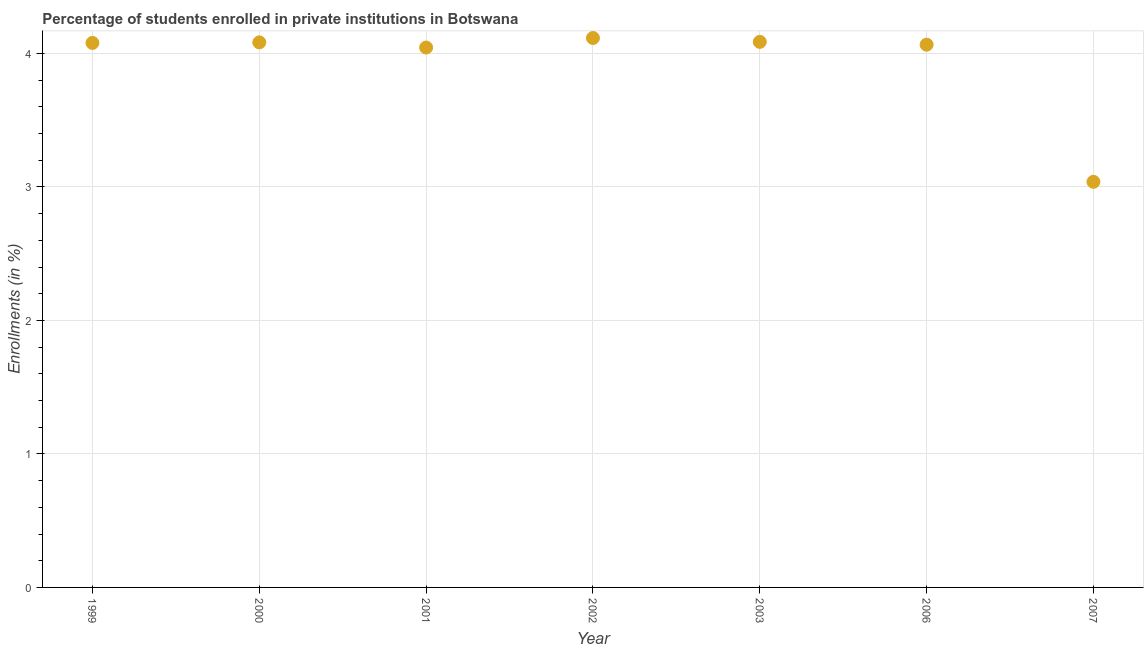What is the enrollments in private institutions in 1999?
Your answer should be very brief. 4.08. Across all years, what is the maximum enrollments in private institutions?
Your answer should be compact. 4.12. Across all years, what is the minimum enrollments in private institutions?
Keep it short and to the point. 3.04. What is the sum of the enrollments in private institutions?
Provide a short and direct response. 27.51. What is the difference between the enrollments in private institutions in 1999 and 2007?
Make the answer very short. 1.04. What is the average enrollments in private institutions per year?
Offer a very short reply. 3.93. What is the median enrollments in private institutions?
Your response must be concise. 4.08. In how many years, is the enrollments in private institutions greater than 3 %?
Make the answer very short. 7. What is the ratio of the enrollments in private institutions in 1999 to that in 2006?
Give a very brief answer. 1. Is the enrollments in private institutions in 2003 less than that in 2006?
Offer a very short reply. No. Is the difference between the enrollments in private institutions in 1999 and 2000 greater than the difference between any two years?
Keep it short and to the point. No. What is the difference between the highest and the second highest enrollments in private institutions?
Provide a succinct answer. 0.03. What is the difference between the highest and the lowest enrollments in private institutions?
Give a very brief answer. 1.08. Does the enrollments in private institutions monotonically increase over the years?
Ensure brevity in your answer.  No. How many dotlines are there?
Ensure brevity in your answer.  1. Does the graph contain any zero values?
Provide a short and direct response. No. Does the graph contain grids?
Provide a short and direct response. Yes. What is the title of the graph?
Your answer should be very brief. Percentage of students enrolled in private institutions in Botswana. What is the label or title of the Y-axis?
Offer a very short reply. Enrollments (in %). What is the Enrollments (in %) in 1999?
Your answer should be very brief. 4.08. What is the Enrollments (in %) in 2000?
Ensure brevity in your answer.  4.08. What is the Enrollments (in %) in 2001?
Ensure brevity in your answer.  4.04. What is the Enrollments (in %) in 2002?
Your answer should be very brief. 4.12. What is the Enrollments (in %) in 2003?
Your answer should be very brief. 4.09. What is the Enrollments (in %) in 2006?
Provide a succinct answer. 4.07. What is the Enrollments (in %) in 2007?
Give a very brief answer. 3.04. What is the difference between the Enrollments (in %) in 1999 and 2000?
Provide a succinct answer. -0. What is the difference between the Enrollments (in %) in 1999 and 2001?
Keep it short and to the point. 0.03. What is the difference between the Enrollments (in %) in 1999 and 2002?
Make the answer very short. -0.04. What is the difference between the Enrollments (in %) in 1999 and 2003?
Your answer should be very brief. -0.01. What is the difference between the Enrollments (in %) in 1999 and 2006?
Offer a terse response. 0.01. What is the difference between the Enrollments (in %) in 1999 and 2007?
Provide a short and direct response. 1.04. What is the difference between the Enrollments (in %) in 2000 and 2001?
Your answer should be very brief. 0.04. What is the difference between the Enrollments (in %) in 2000 and 2002?
Give a very brief answer. -0.03. What is the difference between the Enrollments (in %) in 2000 and 2003?
Your answer should be very brief. -0. What is the difference between the Enrollments (in %) in 2000 and 2006?
Offer a terse response. 0.02. What is the difference between the Enrollments (in %) in 2000 and 2007?
Your answer should be compact. 1.04. What is the difference between the Enrollments (in %) in 2001 and 2002?
Provide a short and direct response. -0.07. What is the difference between the Enrollments (in %) in 2001 and 2003?
Your response must be concise. -0.04. What is the difference between the Enrollments (in %) in 2001 and 2006?
Offer a terse response. -0.02. What is the difference between the Enrollments (in %) in 2001 and 2007?
Give a very brief answer. 1.01. What is the difference between the Enrollments (in %) in 2002 and 2003?
Make the answer very short. 0.03. What is the difference between the Enrollments (in %) in 2002 and 2006?
Give a very brief answer. 0.05. What is the difference between the Enrollments (in %) in 2002 and 2007?
Your answer should be very brief. 1.08. What is the difference between the Enrollments (in %) in 2003 and 2006?
Provide a succinct answer. 0.02. What is the difference between the Enrollments (in %) in 2003 and 2007?
Offer a terse response. 1.05. What is the difference between the Enrollments (in %) in 2006 and 2007?
Your answer should be compact. 1.03. What is the ratio of the Enrollments (in %) in 1999 to that in 2000?
Offer a terse response. 1. What is the ratio of the Enrollments (in %) in 1999 to that in 2003?
Provide a short and direct response. 1. What is the ratio of the Enrollments (in %) in 1999 to that in 2007?
Offer a terse response. 1.34. What is the ratio of the Enrollments (in %) in 2000 to that in 2001?
Keep it short and to the point. 1.01. What is the ratio of the Enrollments (in %) in 2000 to that in 2002?
Your response must be concise. 0.99. What is the ratio of the Enrollments (in %) in 2000 to that in 2006?
Your answer should be very brief. 1. What is the ratio of the Enrollments (in %) in 2000 to that in 2007?
Your answer should be very brief. 1.34. What is the ratio of the Enrollments (in %) in 2001 to that in 2003?
Offer a terse response. 0.99. What is the ratio of the Enrollments (in %) in 2001 to that in 2006?
Provide a succinct answer. 0.99. What is the ratio of the Enrollments (in %) in 2001 to that in 2007?
Offer a terse response. 1.33. What is the ratio of the Enrollments (in %) in 2002 to that in 2007?
Give a very brief answer. 1.35. What is the ratio of the Enrollments (in %) in 2003 to that in 2006?
Provide a succinct answer. 1. What is the ratio of the Enrollments (in %) in 2003 to that in 2007?
Keep it short and to the point. 1.34. What is the ratio of the Enrollments (in %) in 2006 to that in 2007?
Ensure brevity in your answer.  1.34. 